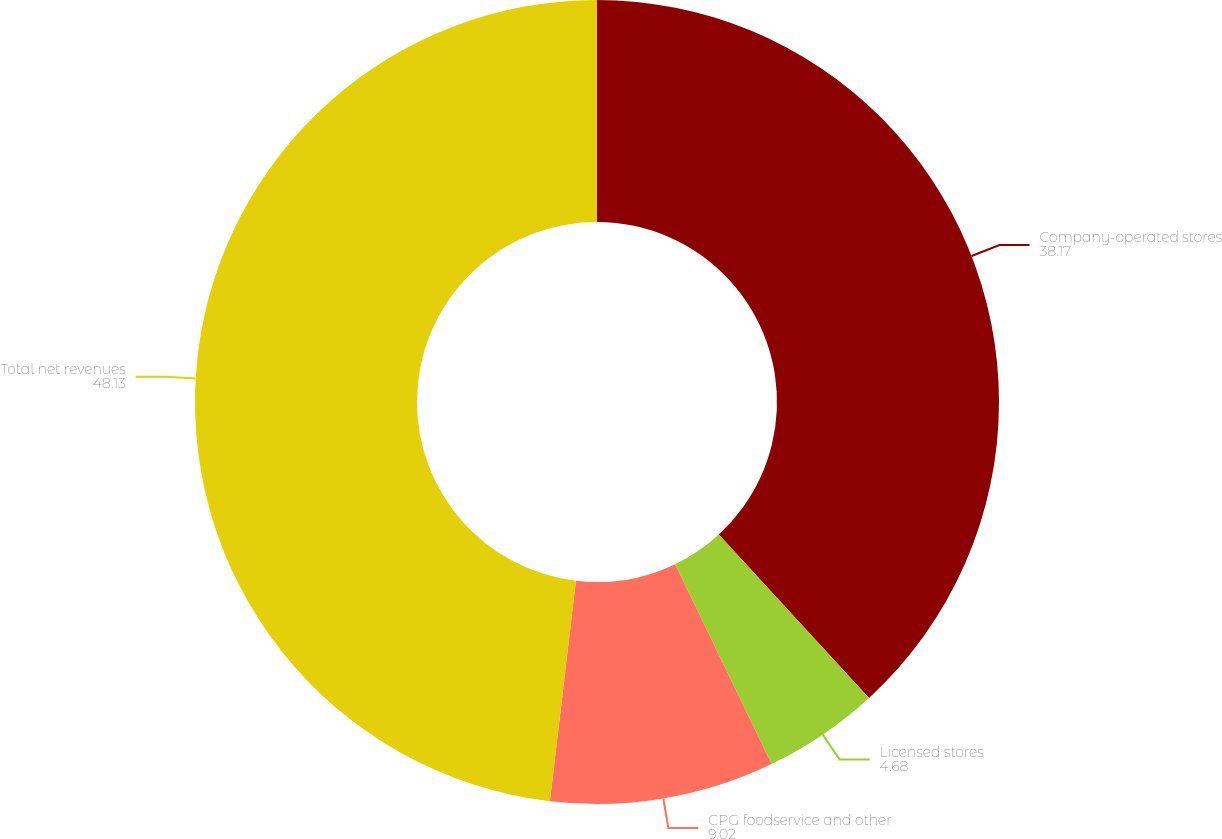<chart> <loc_0><loc_0><loc_500><loc_500><pie_chart><fcel>Company-operated stores<fcel>Licensed stores<fcel>CPG foodservice and other<fcel>Total net revenues<nl><fcel>38.17%<fcel>4.68%<fcel>9.02%<fcel>48.13%<nl></chart> 